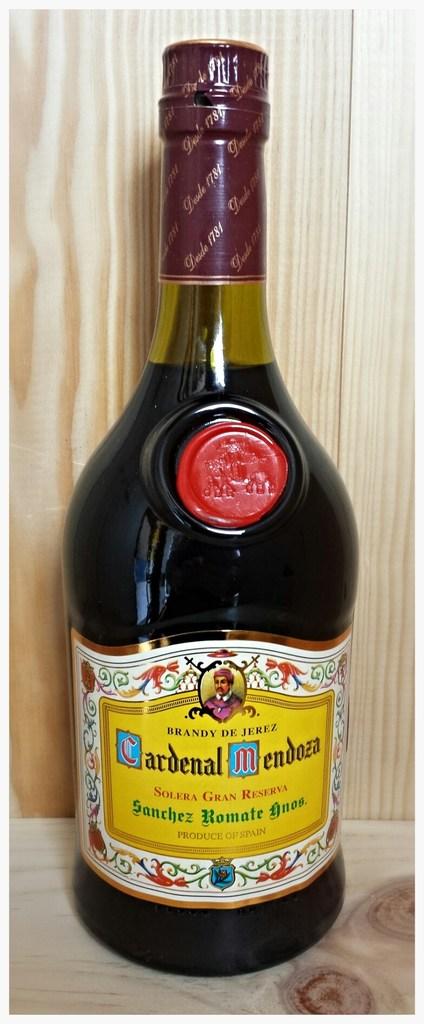What is the name of the brand represented?
Provide a short and direct response. Cardenal mendoza. 